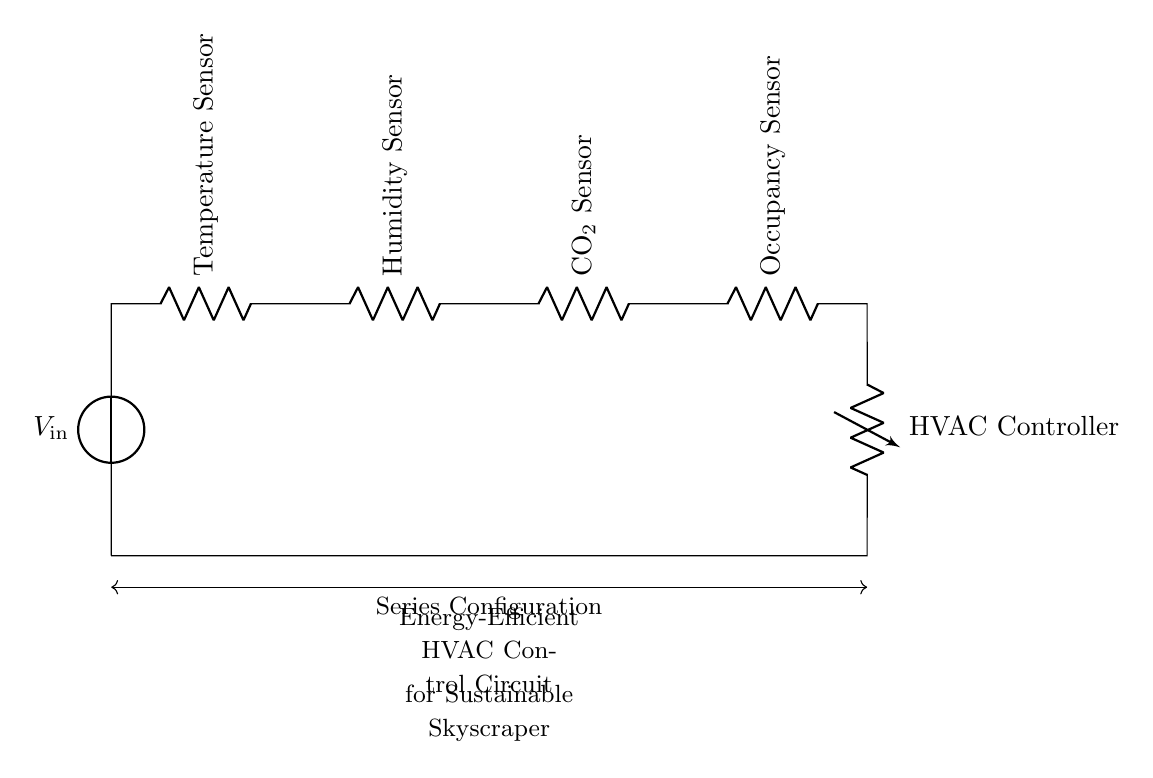What is the input voltage of this circuit? The input voltage is indicated by the voltage source labeled V_in at the top of the circuit diagram. The label clearly signifies the starting voltage for the series circuit.
Answer: V_in How many sensors are in this circuit? Counting the components connected in series, there are four sensors labeled as Temperature Sensor, Humidity Sensor, CO2 Sensor, and Occupancy Sensor. Each is represented distinctly in the diagram.
Answer: Four What is the function of the HVAC Controller in this circuit? The HVAC Controller receives inputs from the sensors and manages the heating, ventilation, and air conditioning system accordingly. Its role is to control environmental conditions based on sensor data.
Answer: Control environmental conditions Which sensors contribute to energy efficiency in the HVAC system? All four sensors (Temperature, Humidity, CO2, and Occupancy) are essential as they provide necessary data for adjusting HVAC operations, ensuring energy efficiency. Each sensor plays a role in optimizing energy usage.
Answer: All four What is the connection type of the components in this circuit? The circuit is configured in a series manner, where components are connected end-to-end, meaning the current must pass through each component in succession. This information is indicated by the accompanying label in the diagram.
Answer: Series How does the occupancy sensor affect HVAC operation? The occupancy sensor detects presence and absence in an area, allowing the HVAC system to adjust based on whether spaces are occupied, which aids in energy conservation. It is pivotal for optimizing energy efficiency based on actual usage.
Answer: Adjust HVAC based on occupancy 